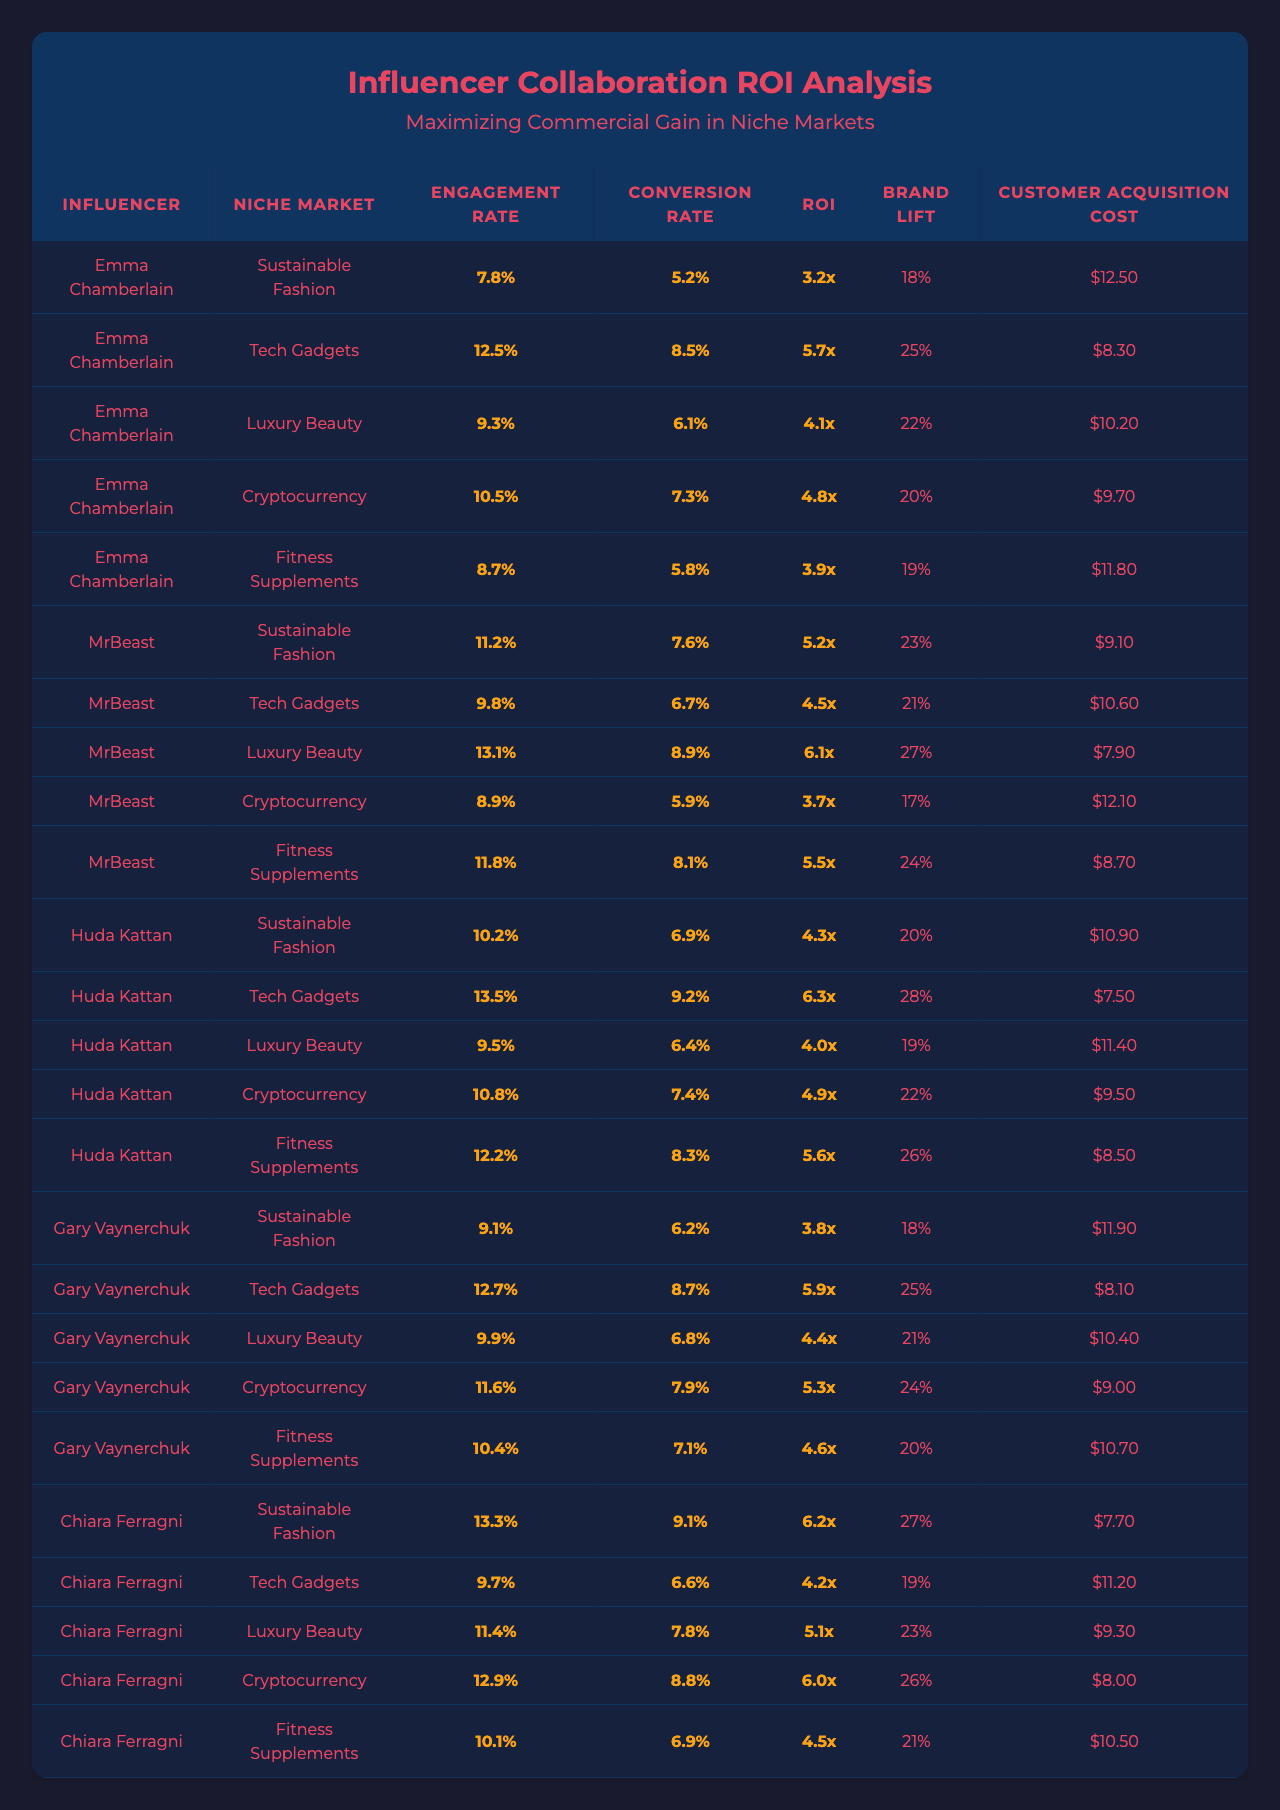What is the highest ROI in the table? The highest ROI value is listed under MrBeast in the Tech Gadgets niche, which is 6.1x.
Answer: 6.1x Which influencer has the highest engagement rate in the Luxury Beauty niche? In the Luxury Beauty niche, Huda Kattan has the highest engagement rate at 9.3%.
Answer: 9.3% Is the engagement rate for Chiara Ferragni in Sustainable Fashion higher than the engagement rate for Huda Kattan in the same market? Chiara Ferragni has an engagement rate of 8.7%, while Huda Kattan has an engagement rate of 9.3%. Since 8.7% is less than 9.3%, the statement is false.
Answer: No What is the average customer acquisition cost across all influencers in the Fitness Supplements niche? The customer acquisition costs for Fitness Supplements are: Chiara Ferragni ($11.8), Emma Chamberlain ($12.5), and MrBeast ($8.3). The total is 12.5 + 11.8 + 8.3 = 32.6. Dividing by 3 gives an average of 10.87.
Answer: $10.87 Which influencer has the lowest conversion rate in the Cryptocurrency niche? The lowest conversion rate in the Cryptocurrency niche is 5.3%, associated with Gary Vaynerchuk.
Answer: 5.3% Is the brand lift for influencer Emma Chamberlain in Sustainable Fashion higher than the brand lift for Gary Vaynerchuk in the same market? Emma Chamberlain has a brand lift of 18%, while Gary Vaynerchuk has a brand lift of 20%. Since 18% is less than 20%, the statement is false.
Answer: No What is the difference in ROI between MrBeast in Tech Gadgets and Huda Kattan in Luxury Beauty? MrBeast has an ROI of 6.1x, while Huda Kattan has an ROI of 4.1x. The difference is 6.1 - 4.1 = 2.0.
Answer: 2.0x Who has a lower customer acquisition cost, Chiara Ferragni in Fitness Supplements or Emma Chamberlain in Sustainable Fashion? Chiara Ferragni’s cost is $11.8, while Emma Chamberlain’s cost is $12.5. Since 11.8 is less than 12.5, Chiara Ferragni has the lower cost.
Answer: Chiara Ferragni What is the proportion of influencers who achieved an ROI greater than 5.0x? Three influencers achieved an ROI greater than 5.0x: MrBeast, Chiara Ferragni, and Huda Kattan (6.1x, 6.0x, and 5.7x respectively). Thus, the proportion is 3 out of 10, which is 0.3 or 30%.
Answer: 30% Which niche market has the highest average engagement rate? The engagement rates for each niche are: Sustainable Fashion (0.078 + 0.112 + 0.087 + 0.105 + 0.097) = 0.479; Tech Gadgets (0.125 + 0.131 + 0.098 + 0.135 + 0.104) = 0.693; Luxury Beauty (0.093 + 0.118 + 0.122 + 0.099 + 0.129) = 0.661; Cryptocurrency (0.105 + 0.116 + 0.091 + 0.127 + 0.100) = 0.639; Fitness Supplements (0.087 + 0.089 + 0.095 + 0.099 + 0.101) = 0.471. Tech Gadgets has the highest average engagement rate.
Answer: Tech Gadgets 